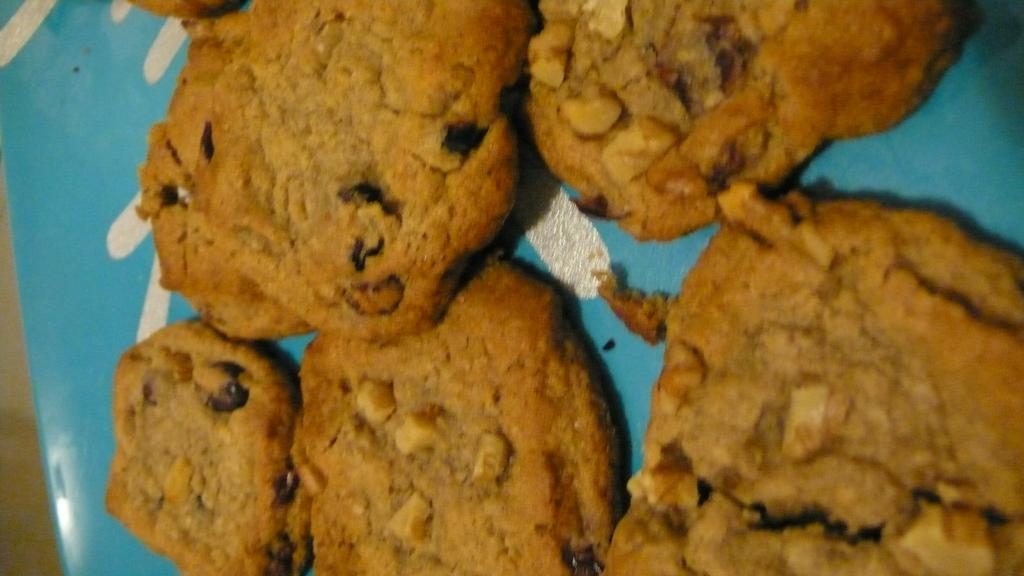What type of food can be seen in the image? There are cookies in the image. What is the cookies placed on? There is a plate in the image. Can you see the owner of the cookies in the image? There is no indication of an owner in the image, as it only shows cookies on a plate. 